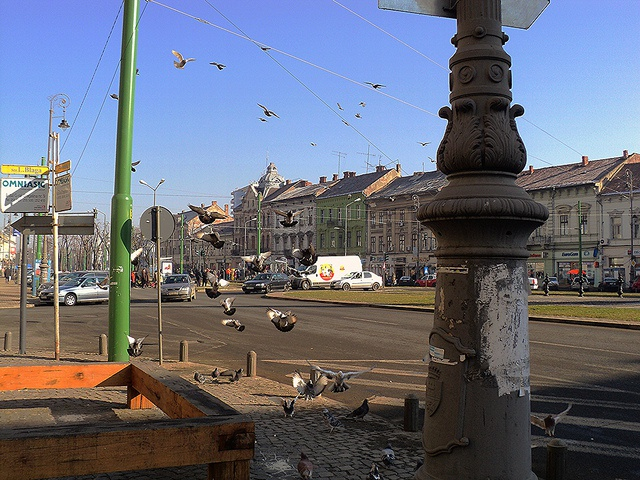Describe the objects in this image and their specific colors. I can see bird in lightblue, black, and gray tones, car in lightblue, gray, white, black, and darkgray tones, truck in lightblue, ivory, gray, black, and darkgray tones, car in lightblue, black, gray, darkgray, and tan tones, and car in lightblue, black, gray, and darkgray tones in this image. 